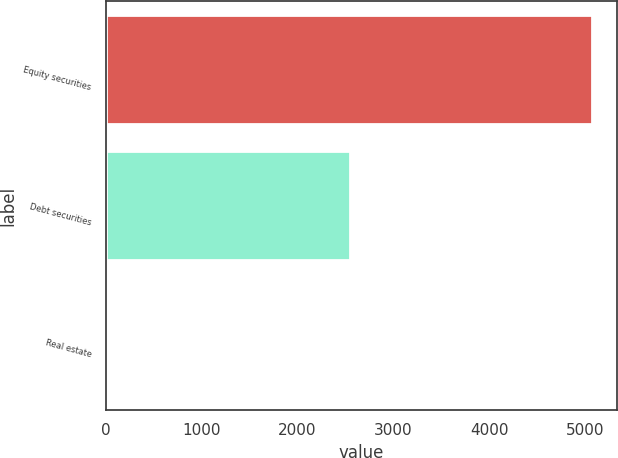<chart> <loc_0><loc_0><loc_500><loc_500><bar_chart><fcel>Equity securities<fcel>Debt securities<fcel>Real estate<nl><fcel>5075<fcel>2550<fcel>5<nl></chart> 